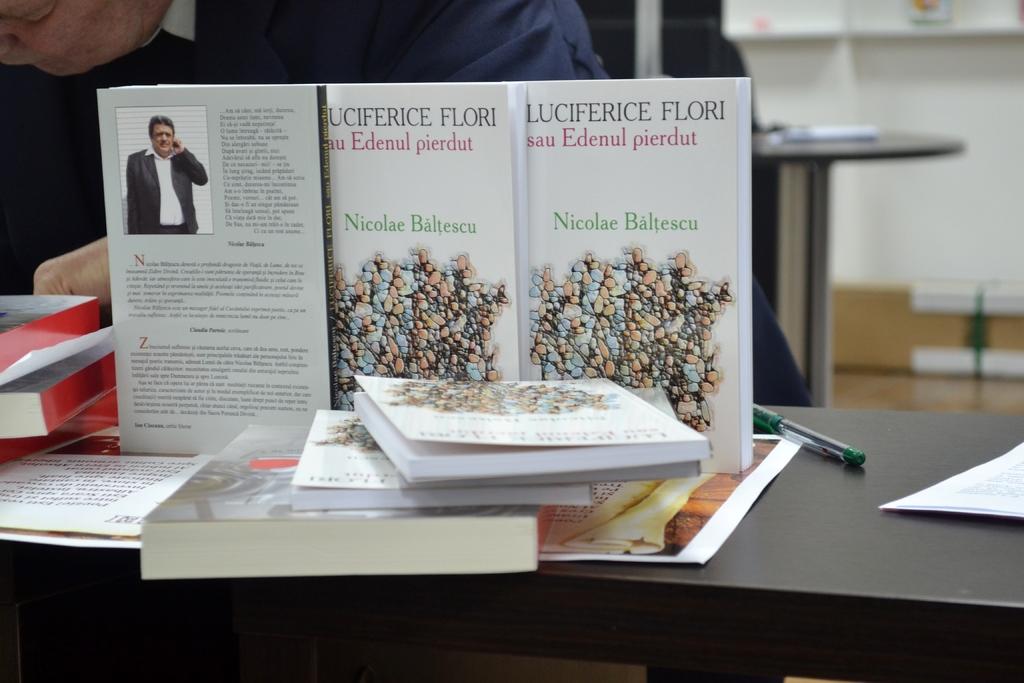Who is the author of the book?
Keep it short and to the point. Nicolae baltescu. What is the title of the book?
Your response must be concise. Luciferice flori. 